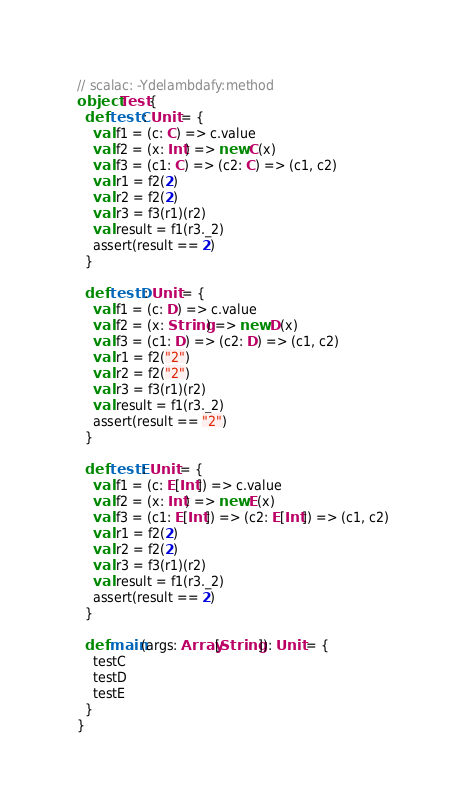<code> <loc_0><loc_0><loc_500><loc_500><_Scala_>// scalac: -Ydelambdafy:method
object Test {
  def testC: Unit = {
    val f1 = (c: C) => c.value
    val f2 = (x: Int) => new C(x)
    val f3 = (c1: C) => (c2: C) => (c1, c2)
    val r1 = f2(2)
    val r2 = f2(2)
    val r3 = f3(r1)(r2)
    val result = f1(r3._2)
    assert(result == 2)
  }

  def testD: Unit = {
    val f1 = (c: D) => c.value
    val f2 = (x: String) => new D(x)
    val f3 = (c1: D) => (c2: D) => (c1, c2)
    val r1 = f2("2")
    val r2 = f2("2")
    val r3 = f3(r1)(r2)
    val result = f1(r3._2)
    assert(result == "2")
  }

  def testE: Unit = {
    val f1 = (c: E[Int]) => c.value
    val f2 = (x: Int) => new E(x)
    val f3 = (c1: E[Int]) => (c2: E[Int]) => (c1, c2)
    val r1 = f2(2)
    val r2 = f2(2)
    val r3 = f3(r1)(r2)
    val result = f1(r3._2)
    assert(result == 2)
  }

  def main(args: Array[String]): Unit = {
    testC
    testD
    testE
  }
}
</code> 